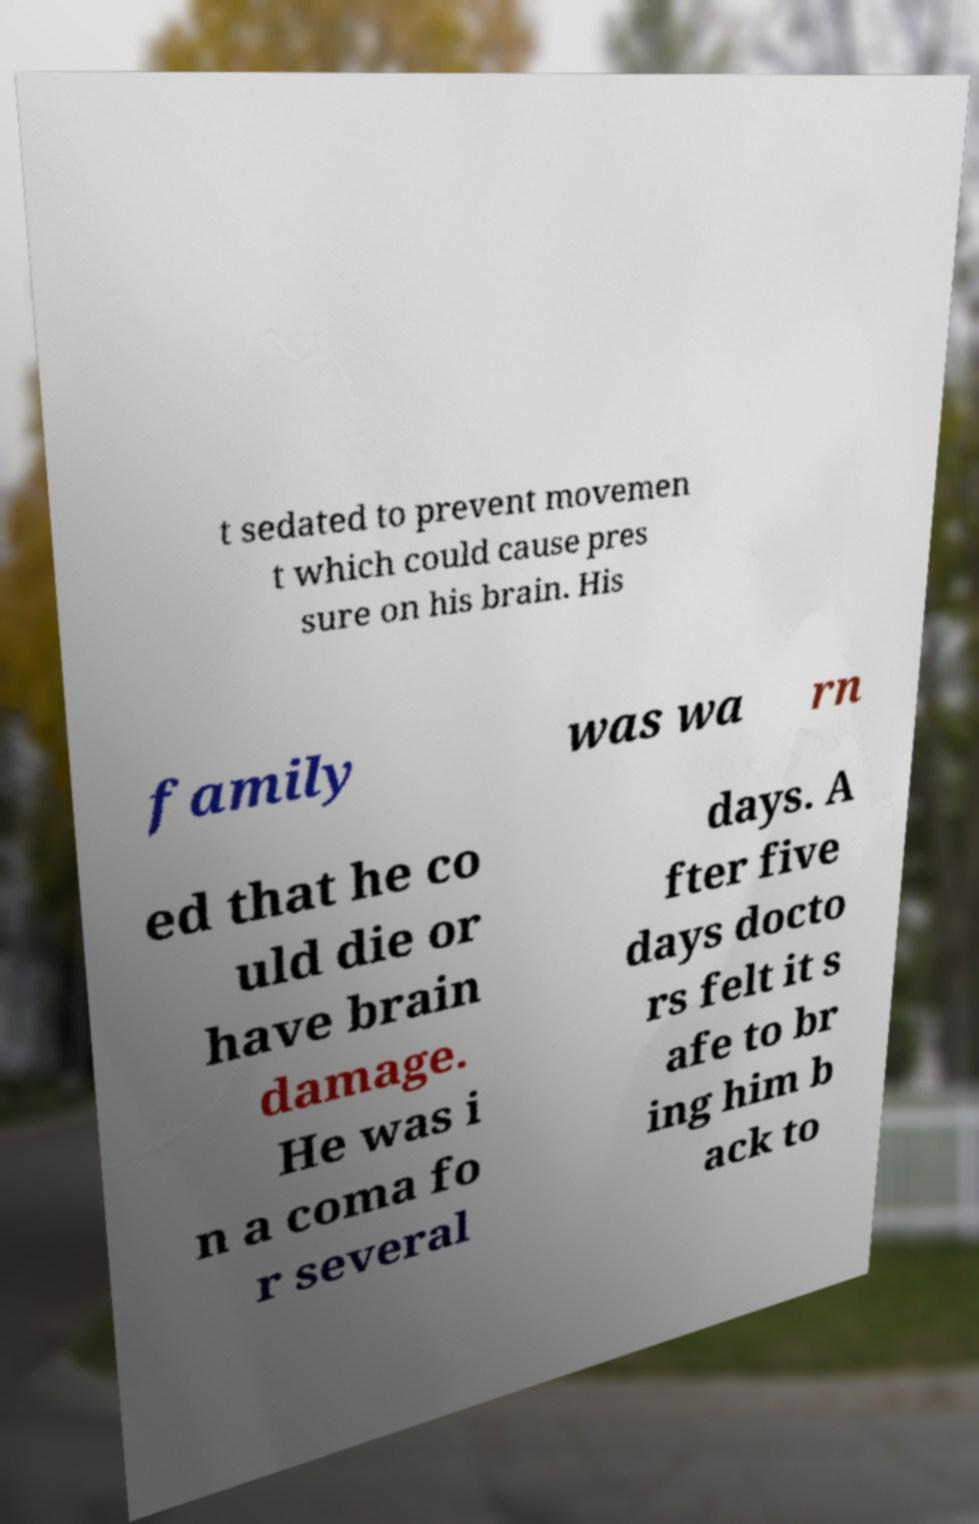What messages or text are displayed in this image? I need them in a readable, typed format. t sedated to prevent movemen t which could cause pres sure on his brain. His family was wa rn ed that he co uld die or have brain damage. He was i n a coma fo r several days. A fter five days docto rs felt it s afe to br ing him b ack to 